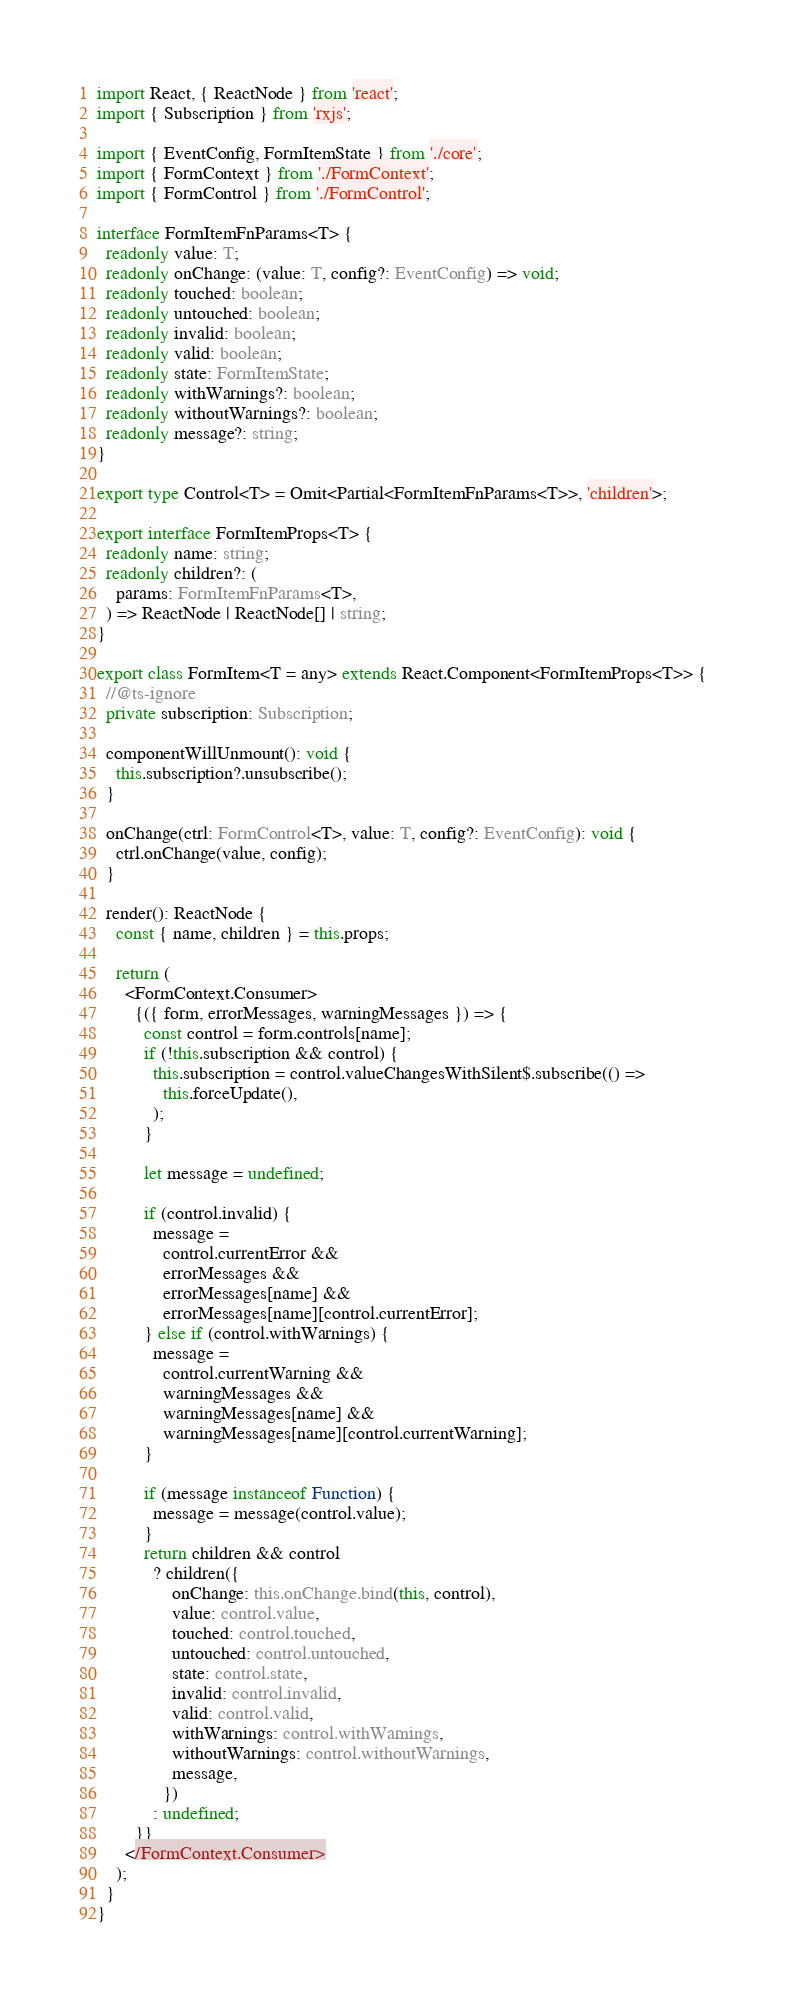Convert code to text. <code><loc_0><loc_0><loc_500><loc_500><_TypeScript_>import React, { ReactNode } from 'react';
import { Subscription } from 'rxjs';

import { EventConfig, FormItemState } from './core';
import { FormContext } from './FormContext';
import { FormControl } from './FormControl';

interface FormItemFnParams<T> {
  readonly value: T;
  readonly onChange: (value: T, config?: EventConfig) => void;
  readonly touched: boolean;
  readonly untouched: boolean;
  readonly invalid: boolean;
  readonly valid: boolean;
  readonly state: FormItemState;
  readonly withWarnings?: boolean;
  readonly withoutWarnings?: boolean;
  readonly message?: string;
}

export type Control<T> = Omit<Partial<FormItemFnParams<T>>, 'children'>;

export interface FormItemProps<T> {
  readonly name: string;
  readonly children?: (
    params: FormItemFnParams<T>,
  ) => ReactNode | ReactNode[] | string;
}

export class FormItem<T = any> extends React.Component<FormItemProps<T>> {
  //@ts-ignore
  private subscription: Subscription;

  componentWillUnmount(): void {
    this.subscription?.unsubscribe();
  }

  onChange(ctrl: FormControl<T>, value: T, config?: EventConfig): void {
    ctrl.onChange(value, config);
  }

  render(): ReactNode {
    const { name, children } = this.props;

    return (
      <FormContext.Consumer>
        {({ form, errorMessages, warningMessages }) => {
          const control = form.controls[name];
          if (!this.subscription && control) {
            this.subscription = control.valueChangesWithSilent$.subscribe(() =>
              this.forceUpdate(),
            );
          }

          let message = undefined;

          if (control.invalid) {
            message =
              control.currentError &&
              errorMessages &&
              errorMessages[name] &&
              errorMessages[name][control.currentError];
          } else if (control.withWarnings) {
            message =
              control.currentWarning &&
              warningMessages &&
              warningMessages[name] &&
              warningMessages[name][control.currentWarning];
          }

          if (message instanceof Function) {
            message = message(control.value);
          }
          return children && control
            ? children({
                onChange: this.onChange.bind(this, control),
                value: control.value,
                touched: control.touched,
                untouched: control.untouched,
                state: control.state,
                invalid: control.invalid,
                valid: control.valid,
                withWarnings: control.withWarnings,
                withoutWarnings: control.withoutWarnings,
                message,
              })
            : undefined;
        }}
      </FormContext.Consumer>
    );
  }
}
</code> 